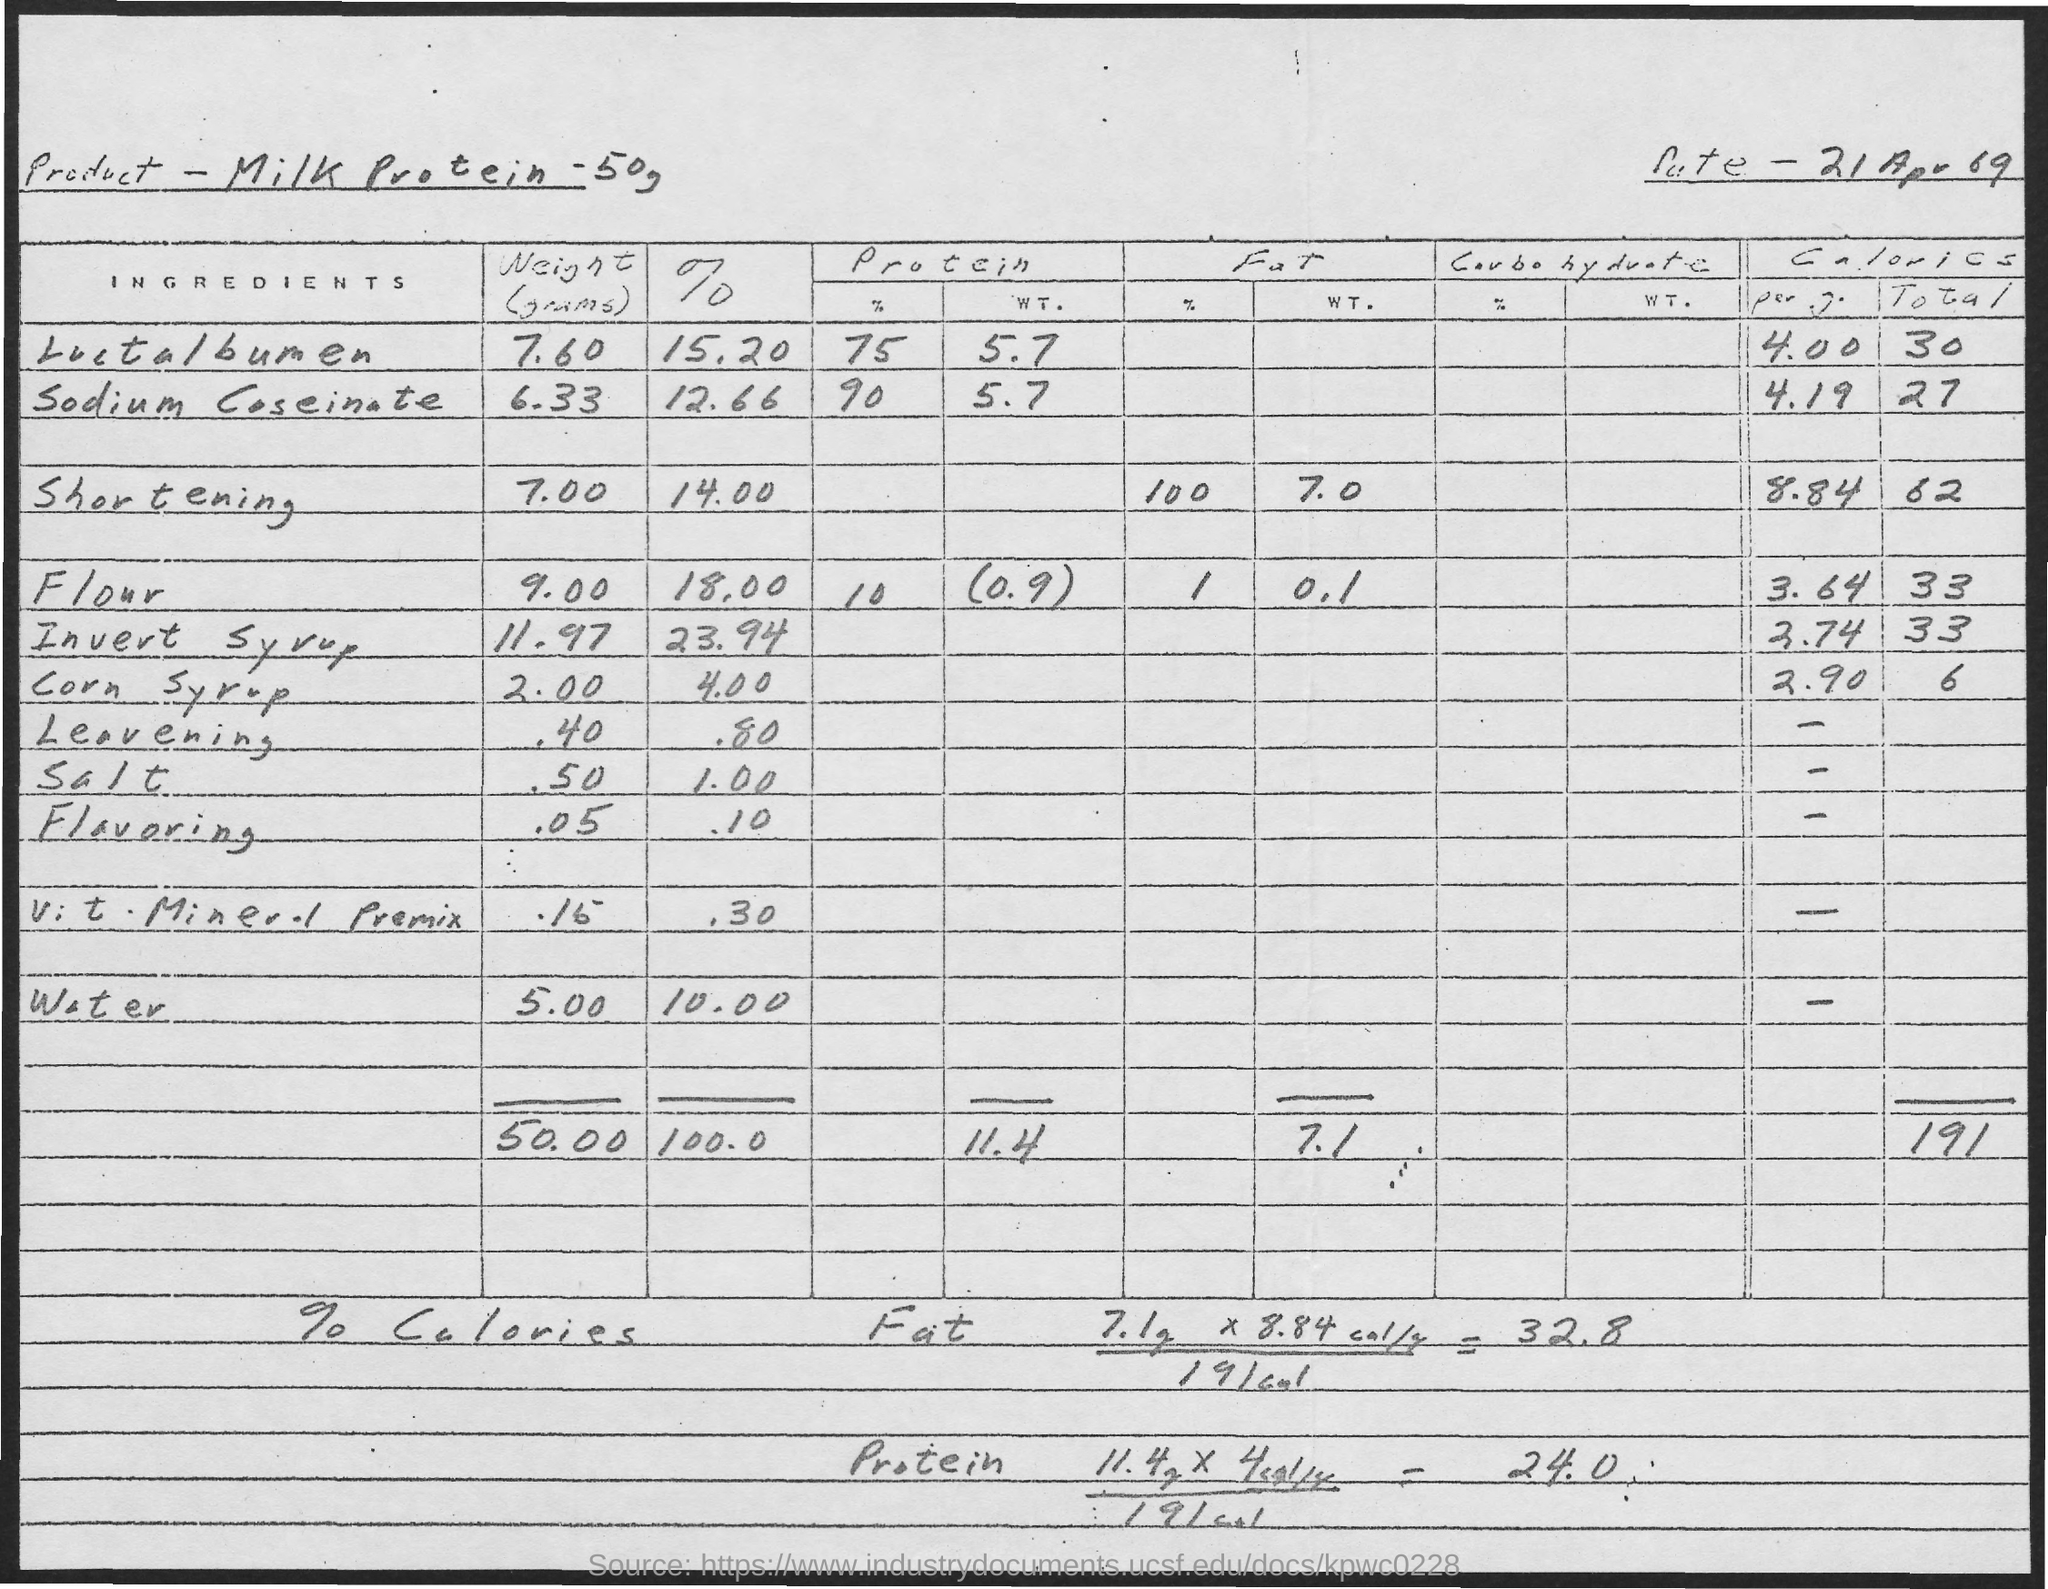How is the percentage of calories from fat calculated in this document? The document seems to calculate the percentage of calories from fat using a handwritten formula at the bottom. It multiplies the fat percentage (7.1%) with a constant (8.84%%, which may refer to the number of calories per gram of fat), resulting in 32.8%, indicating the proportion of the product's total calories derived from fat. 